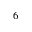<formula> <loc_0><loc_0><loc_500><loc_500>^ { 6 }</formula> 